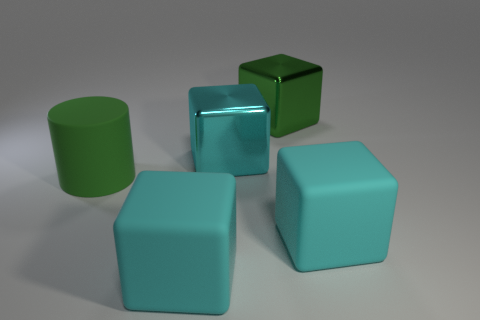The rubber cylinder that is the same size as the cyan metallic thing is what color?
Keep it short and to the point. Green. Is the shape of the green rubber thing the same as the cyan shiny object?
Ensure brevity in your answer.  No. There is a big green thing on the left side of the cyan metal object; what is its material?
Ensure brevity in your answer.  Rubber. The large cylinder has what color?
Your answer should be compact. Green. Does the green object that is right of the big green rubber thing have the same size as the cyan shiny cube to the right of the big rubber cylinder?
Make the answer very short. Yes. What size is the rubber thing that is left of the big cyan shiny object and in front of the large matte cylinder?
Make the answer very short. Large. There is another metallic object that is the same shape as the cyan metallic object; what color is it?
Make the answer very short. Green. Is the number of big cyan metallic cubes on the right side of the large cyan metal object greater than the number of shiny objects that are to the right of the large green matte object?
Give a very brief answer. No. How many other objects are there of the same shape as the large green rubber object?
Make the answer very short. 0. There is a large cyan block that is behind the large matte cylinder; is there a green cylinder in front of it?
Offer a very short reply. Yes. 